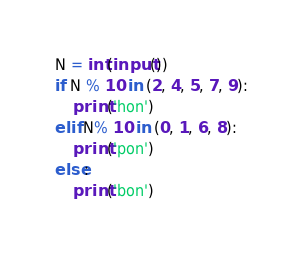<code> <loc_0><loc_0><loc_500><loc_500><_Python_>N = int(input())
if N % 10 in (2, 4, 5, 7, 9):
    print('hon')
elif N% 10 in (0, 1, 6, 8):
    print('pon')
else:
    print('bon')</code> 